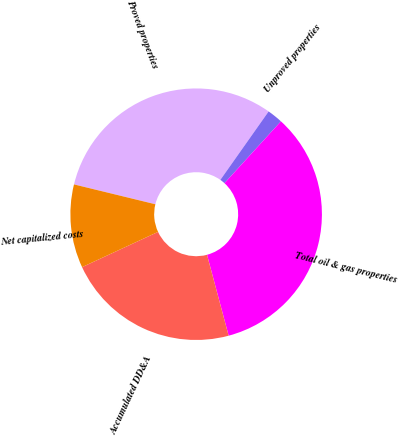<chart> <loc_0><loc_0><loc_500><loc_500><pie_chart><fcel>Proved properties<fcel>Unproved properties<fcel>Total oil & gas properties<fcel>Accumulated DD&A<fcel>Net capitalized costs<nl><fcel>30.97%<fcel>2.0%<fcel>34.07%<fcel>22.25%<fcel>10.72%<nl></chart> 